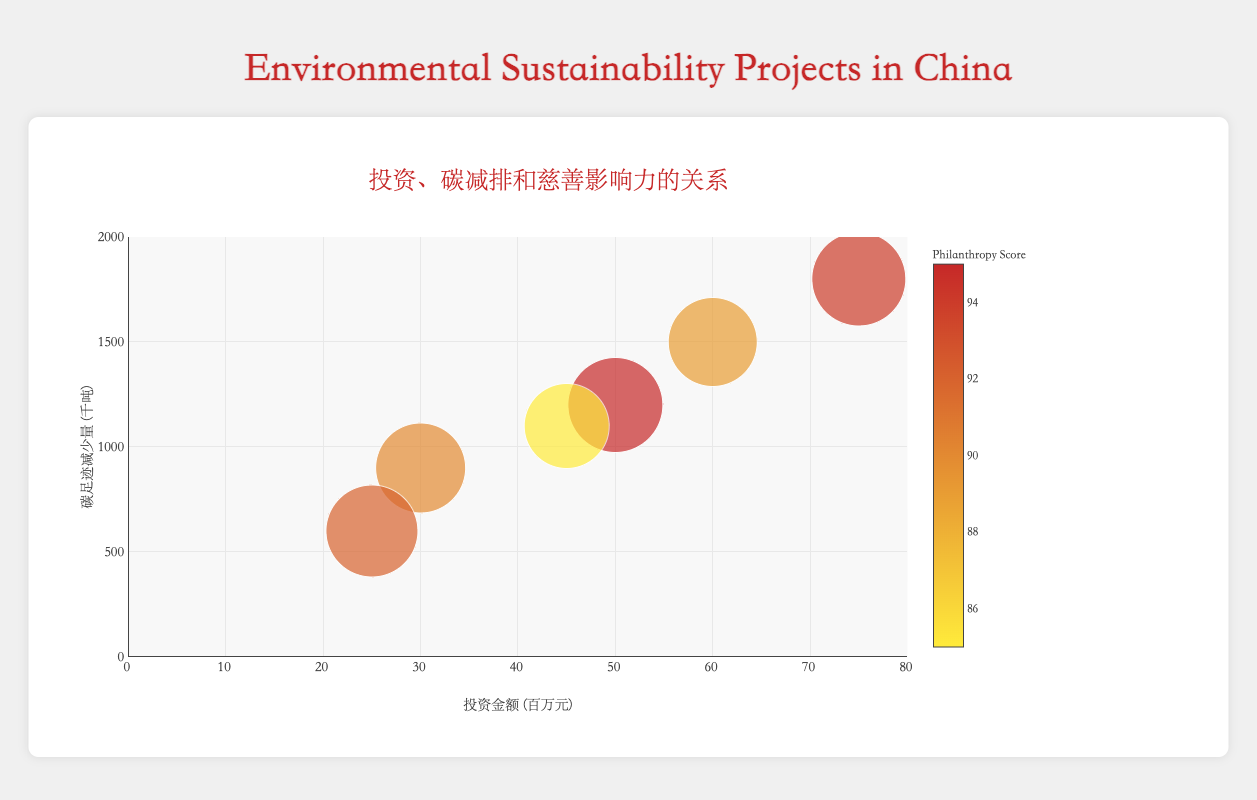How many environmental sustainability projects are displayed in the figure? Count the number of bubbles in the bubble chart. Each bubble represents one project.
Answer: 6 Which project has the highest investment amount? Look at the x-axis to find the bubble farthest to the right. The Beijing Electric Vehicles Subsidy project has the highest investment, indicated by its far-right position on the x-axis.
Answer: Beijing Electric Vehicles Subsidy What is the philanthropy score of the project with the lowest carbon footprint reduction? Find the bubble closest to the bottom on the y-axis. The Hainan Reforestation Effort has the lowest carbon footprint reduction. Check the size and color of this corresponding bubble to find its philanthropy score of 92.
Answer: 92 What is the range of carbon footprint reduction among all projects? Identify the minimum and maximum values on the y-axis and calculate the difference. The minimum carbon footprint reduction is 600,000 tons (Hainan Reforestation Effort), and the maximum is 1,800,000 tons (Beijing Electric Vehicles Subsidy), giving a range of 1,800,000 - 600,000 = 1,200,000 tons.
Answer: 1,200,000 tons Comparing the "Green Belt Initiative" and "Solar Valley Project", which has a higher carbon footprint reduction and by how much? Find the two bubbles based on their positions on the chart. The y-axis values will show their carbon footprint reductions. The Green Belt Initiative reduces 1,200,000 tons, while the Solar Valley Project reduces 900,000 tons, the difference is 1,200,000 - 900,000 = 300,000 tons.
Answer: Green Belt Initiative by 300,000 tons Which project has the smallest bubble, and what does it signify? The size of the bubbles correlates to the philanthropy score. Identify the smallest bubble and its project. The Shanghai Clean Air Program has the smallest bubble, indicating the lowest philanthropy score among the shown projects, which is 85.
Answer: Shanghai Clean Air Program with a philanthropy score of 85 What is the median investment amount of the projects? List the investment amounts: 25000000, 30000000, 45000000, 50000000, 60000000, 75000000. Since there are 6 values, the median is the average of the 3rd and 4th values, (45000000 + 50000000) / 2 = 47500000.
Answer: ¥47.5 million How does the "Guangdong Wind Power Development" project compare in terms of philanthropy score to the other projects? Determine where the project falls on the colorscale. Guangdong Wind Power Development has a philanthropy score of 89. Compare this score against the philanthropy scores of the other projects: 95, 90, 85, 92, 94. Guangdong Wind Power Development's philanthropy score is above Shanghai Clean Air Program and Solar Valley Project and below the other three projects.
Answer: Higher than two projects, lower than three projects What is the average carbon footprint reduction of all projects? Add all the carbon footprint reductions and divide by the number of projects. (1200000 + 900000 + 1100000 + 600000 + 1500000 + 1800000) / 6 = 7100000 / 6 ≈ 1,183,333.33 tons.
Answer: 1,183,333.33 tons 